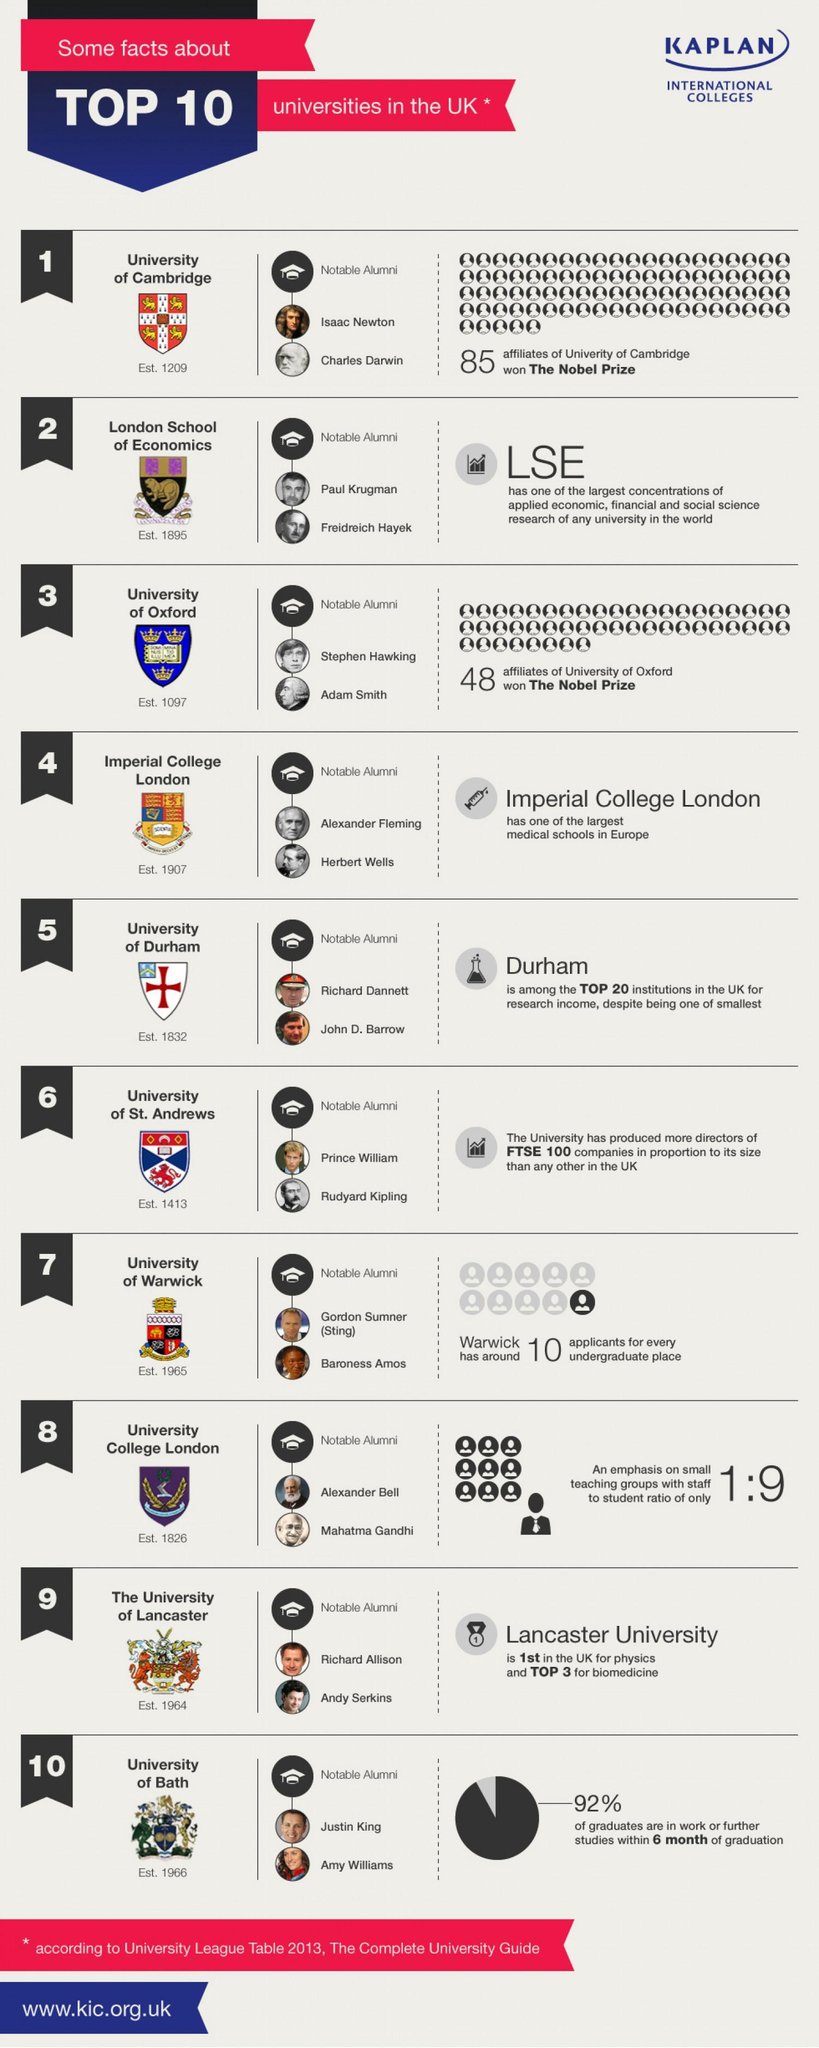Which university was Rudyard Kipling part of?
Answer the question with a short phrase. University of St. Andrews Which university has one teacher for every 9 students? University College London Which University had more affiliates winning the Nobel Prize among those listed? University of Cambridge When was the university where Andy Serkins studied established? 1964 Name two alumni of the university established in 1097. Stephen Hawking, Adam Smith Which British royalty is mentioned in the list of notable alumni? Prince William Which Indian leader was the alumnus of University College London? Mahatma Gandhi Which university has a very high percent of graduates enrolling in work within months of their graduation? University of Bath Which two famous personalities were part of University of Cambridge? Isaac Newton, Charles Darwin 